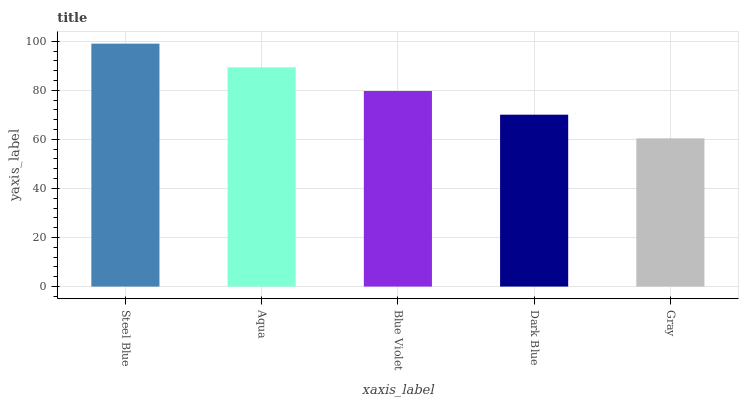Is Gray the minimum?
Answer yes or no. Yes. Is Steel Blue the maximum?
Answer yes or no. Yes. Is Aqua the minimum?
Answer yes or no. No. Is Aqua the maximum?
Answer yes or no. No. Is Steel Blue greater than Aqua?
Answer yes or no. Yes. Is Aqua less than Steel Blue?
Answer yes or no. Yes. Is Aqua greater than Steel Blue?
Answer yes or no. No. Is Steel Blue less than Aqua?
Answer yes or no. No. Is Blue Violet the high median?
Answer yes or no. Yes. Is Blue Violet the low median?
Answer yes or no. Yes. Is Gray the high median?
Answer yes or no. No. Is Steel Blue the low median?
Answer yes or no. No. 